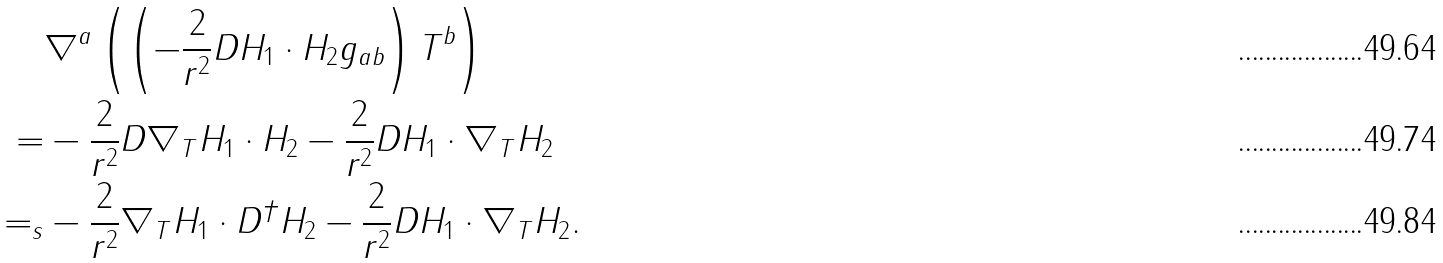<formula> <loc_0><loc_0><loc_500><loc_500>& \nabla ^ { a } \left ( \left ( - \frac { 2 } { r ^ { 2 } } D H _ { 1 } \cdot H _ { 2 } g _ { a b } \right ) T ^ { b } \right ) \\ = & - \frac { 2 } { r ^ { 2 } } D \nabla _ { T } H _ { 1 } \cdot H _ { 2 } - \frac { 2 } { r ^ { 2 } } D H _ { 1 } \cdot \nabla _ { T } H _ { 2 } \\ = _ { s } & - \frac { 2 } { r ^ { 2 } } \nabla _ { T } H _ { 1 } \cdot D ^ { \dagger } H _ { 2 } - \frac { 2 } { r ^ { 2 } } D H _ { 1 } \cdot \nabla _ { T } H _ { 2 } .</formula> 